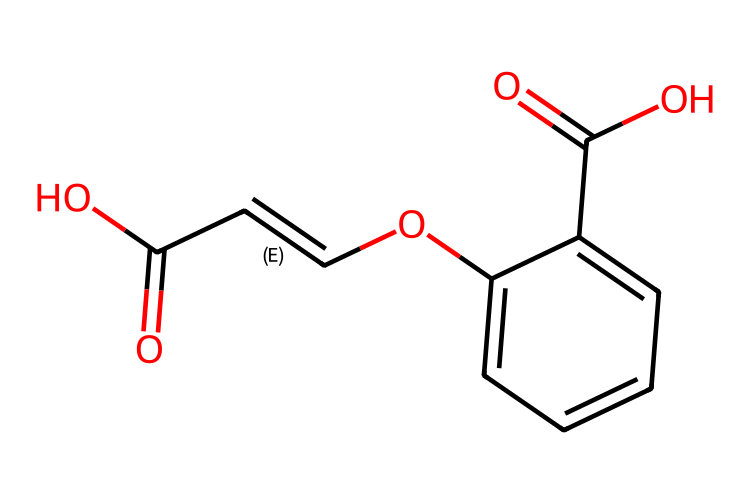How many carbon atoms are in the molecule? By examining the SMILES representation, we can count the carbon atoms represented by 'C'. There are 10 'C' symbols, indicating 10 carbon atoms.
Answer: 10 What is the functional group indicated in the structure? The 'C(=O)O' part shows a carbon atom double-bonded to an oxygen and single-bonded to a hydroxyl group, indicating a carboxylic acid functional group.
Answer: carboxylic acid Is there geometric isomerism present in this compound? The presence of a double bond in the structure allows for the possibility of cis/trans isomerism based on the substitution patterns around the double bond, confirming geometric isomerism.
Answer: yes How many double bonds are present in this molecule? Observing the structure, there are two instances of 'C=C' and 'C(=O)', both indicating double bonds; therefore, there are three double bonds in total.
Answer: 3 What are the positions of the hydroxyl groups in the structure? The structure shows hydroxyl groups at positions 4 and 5 (on the benzene ring), and this can be deduced by noting the 'O' atoms connected directly to the ring.
Answer: 4 and 5 What type of geometric isomerism can occur in this compound? Due to the arrangement around the double bond in the side chain, the molecule can exhibit cis and trans orientations based on how substituents are arranged relative to each other.
Answer: cis/trans 